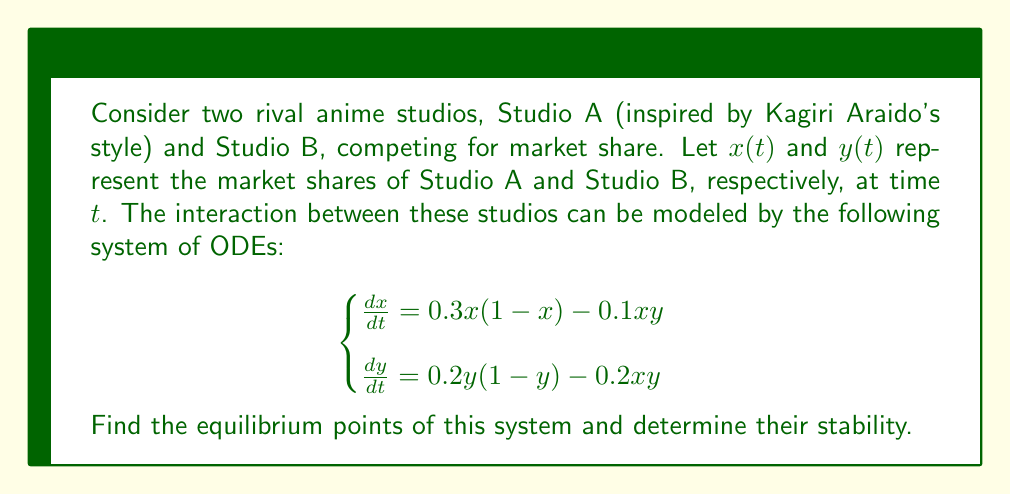Provide a solution to this math problem. To solve this problem, we'll follow these steps:

1) Find the equilibrium points by setting both derivatives to zero.
2) Analyze the stability of each equilibrium point using the Jacobian matrix.

Step 1: Finding equilibrium points

Set both derivatives to zero:

$$\begin{cases}
0.3x(1-x) - 0.1xy = 0 \\
0.2y(1-y) - 0.2xy = 0
\end{cases}$$

From the first equation:
$x(0.3 - 0.3x - 0.1y) = 0$
So either $x = 0$ or $0.3 - 0.3x - 0.1y = 0$

From the second equation:
$y(0.2 - 0.2y - 0.2x) = 0$
So either $y = 0$ or $0.2 - 0.2y - 0.2x = 0$

Considering all possibilities:

a) If $x = 0$ and $y = 0$, we get the equilibrium point $(0, 0)$
b) If $x = 0$ and $y \neq 0$, then $y = 1$ from the second equation, giving $(0, 1)$
c) If $x \neq 0$ and $y = 0$, then $x = 1$ from the first equation, giving $(1, 0)$
d) If $x \neq 0$ and $y \neq 0$, we solve:

   $0.3 - 0.3x - 0.1y = 0$
   $0.2 - 0.2y - 0.2x = 0$

   Solving these simultaneously gives $x = \frac{5}{7}$, $y = \frac{3}{7}$

So, the equilibrium points are: $(0, 0)$, $(1, 0)$, $(0, 1)$, and $(\frac{5}{7}, \frac{3}{7})$

Step 2: Analyzing stability

To analyze stability, we need to find the Jacobian matrix:

$$J = \begin{bmatrix}
\frac{\partial}{\partial x}(0.3x(1-x) - 0.1xy) & \frac{\partial}{\partial y}(0.3x(1-x) - 0.1xy) \\
\frac{\partial}{\partial x}(0.2y(1-y) - 0.2xy) & \frac{\partial}{\partial y}(0.2y(1-y) - 0.2xy)
\end{bmatrix}$$

$$J = \begin{bmatrix}
0.3 - 0.6x - 0.1y & -0.1x \\
-0.2y & 0.2 - 0.4y - 0.2x
\end{bmatrix}$$

Now, we evaluate this Jacobian at each equilibrium point and find its eigenvalues:

1) At $(0, 0)$: 
   $J = \begin{bmatrix} 0.3 & 0 \\ 0 & 0.2 \end{bmatrix}$
   Eigenvalues: 0.3 and 0.2 (both positive) => Unstable node

2) At $(1, 0)$:
   $J = \begin{bmatrix} -0.3 & -0.1 \\ 0 & 0 \end{bmatrix}$
   Eigenvalues: -0.3 and 0 => Saddle point

3) At $(0, 1)$:
   $J = \begin{bmatrix} 0.2 & 0 \\ -0.2 & -0.2 \end{bmatrix}$
   Eigenvalues: 0.2 and -0.2 => Saddle point

4) At $(\frac{5}{7}, \frac{3}{7})$:
   $J = \begin{bmatrix} -0.15 & -\frac{1}{14} \\ -\frac{6}{35} & -0.06 \end{bmatrix}$
   Eigenvalues: approximately -0.1054 and -0.1046 (both negative) => Stable node
Answer: The system has four equilibrium points: $(0, 0)$, $(1, 0)$, $(0, 1)$, and $(\frac{5}{7}, \frac{3}{7})$. 
$(0, 0)$ is an unstable node, $(1, 0)$ and $(0, 1)$ are saddle points, and $(\frac{5}{7}, \frac{3}{7})$ is a stable node. 